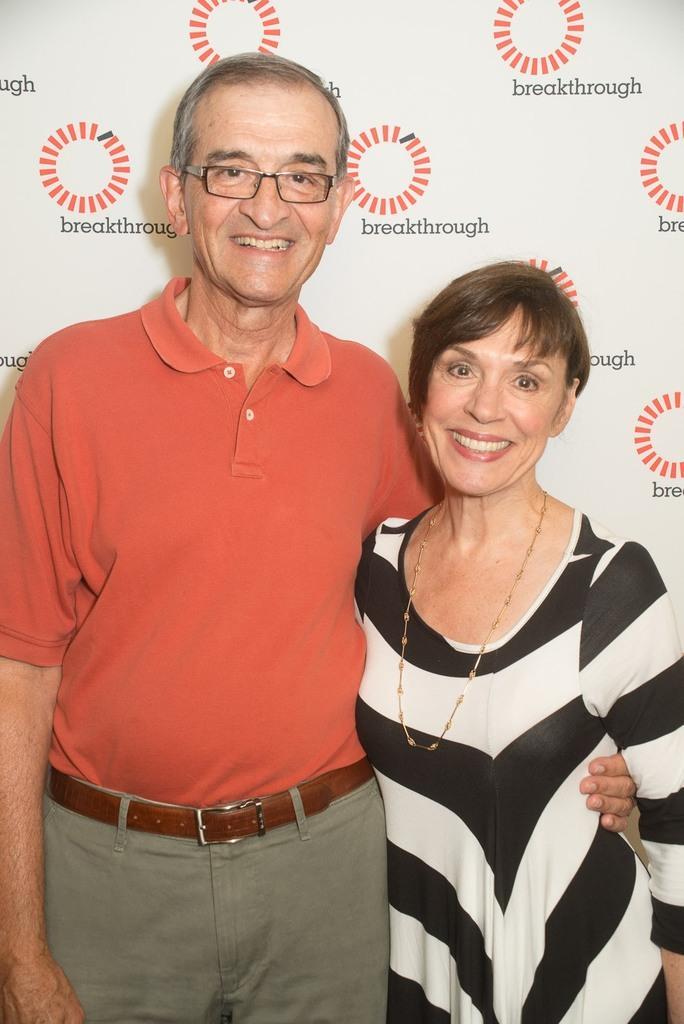Describe this image in one or two sentences. In this image, we can see a man and a woman standing, they are smiling, in the background we can see a poster. 